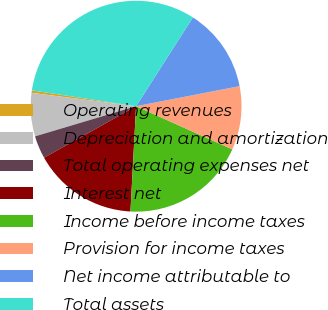<chart> <loc_0><loc_0><loc_500><loc_500><pie_chart><fcel>Operating revenues<fcel>Depreciation and amortization<fcel>Total operating expenses net<fcel>Interest net<fcel>Income before income taxes<fcel>Provision for income taxes<fcel>Net income attributable to<fcel>Total assets<nl><fcel>0.38%<fcel>6.64%<fcel>3.51%<fcel>16.02%<fcel>19.14%<fcel>9.76%<fcel>12.89%<fcel>31.65%<nl></chart> 